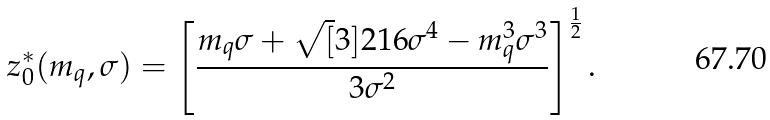Convert formula to latex. <formula><loc_0><loc_0><loc_500><loc_500>z _ { 0 } ^ { * } ( m _ { q } , \sigma ) = \left [ \frac { m _ { q } \sigma + \sqrt { [ } 3 ] { 2 1 6 \sigma ^ { 4 } - m _ { q } ^ { 3 } \sigma ^ { 3 } } } { 3 \sigma ^ { 2 } } \right ] ^ { \frac { 1 } { 2 } } .</formula> 